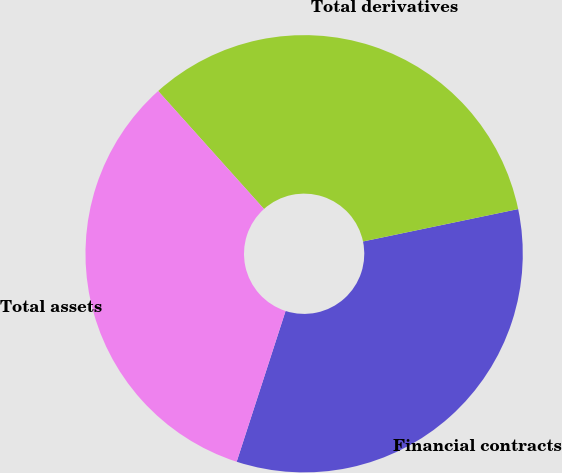<chart> <loc_0><loc_0><loc_500><loc_500><pie_chart><fcel>Financial contracts<fcel>Total derivatives<fcel>Total assets<nl><fcel>33.27%<fcel>33.36%<fcel>33.37%<nl></chart> 